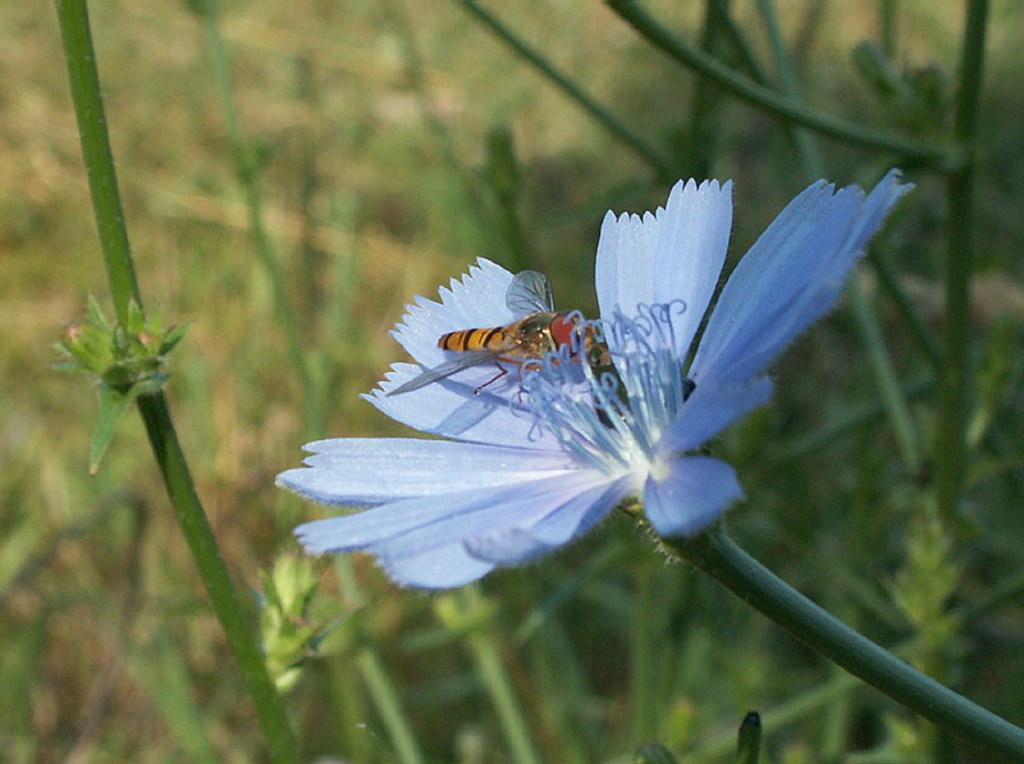What type of flower can be seen in the image? There is a blue flower on a stem in the image. Is there any other living organism interacting with the flower? Yes, a bee is present on the flower. What else can be seen in the background of the image? There are stems and leaves visible in the background of the image. What type of music can be heard coming from the flower in the image? There is no music present in the image; it is a photograph of a blue flower with a bee on it. 